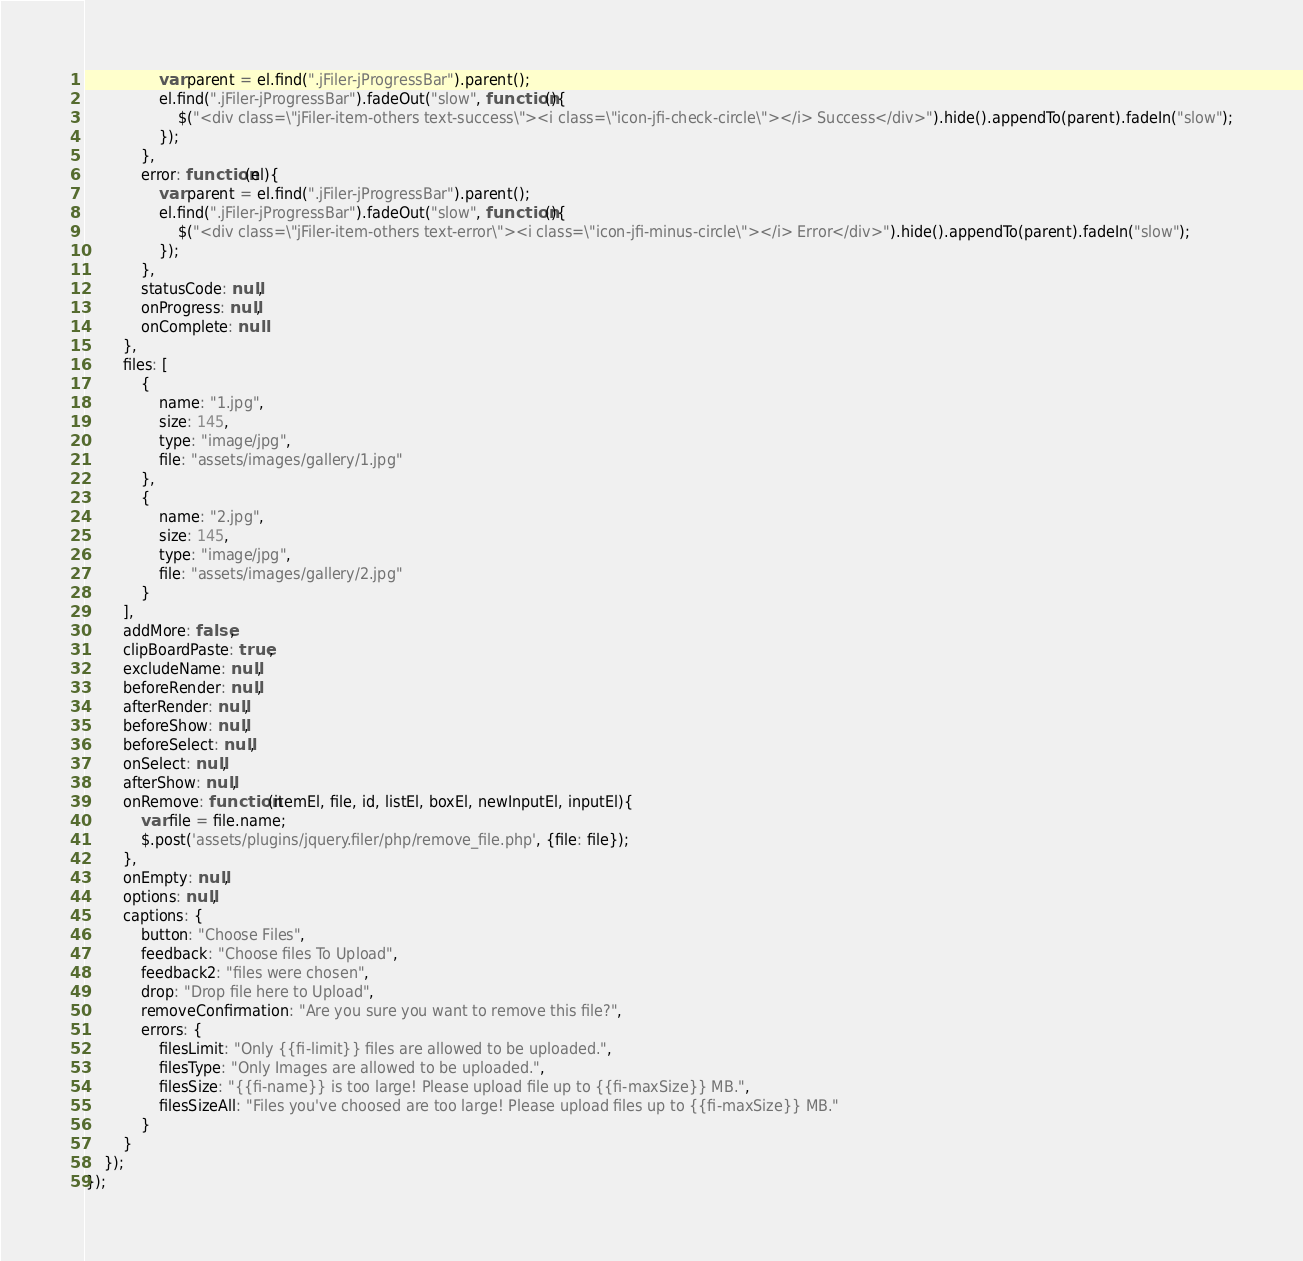<code> <loc_0><loc_0><loc_500><loc_500><_JavaScript_>                var parent = el.find(".jFiler-jProgressBar").parent();
                el.find(".jFiler-jProgressBar").fadeOut("slow", function(){
                    $("<div class=\"jFiler-item-others text-success\"><i class=\"icon-jfi-check-circle\"></i> Success</div>").hide().appendTo(parent).fadeIn("slow");
                });
            },
            error: function(el){
                var parent = el.find(".jFiler-jProgressBar").parent();
                el.find(".jFiler-jProgressBar").fadeOut("slow", function(){
                    $("<div class=\"jFiler-item-others text-error\"><i class=\"icon-jfi-minus-circle\"></i> Error</div>").hide().appendTo(parent).fadeIn("slow");
                });
            },
            statusCode: null,
            onProgress: null,
            onComplete: null
        },
		files: [
			{
				name: "1.jpg",
				size: 145,
				type: "image/jpg",
				file: "assets/images/gallery/1.jpg"
			},
			{
				name: "2.jpg",
				size: 145,
				type: "image/jpg",
				file: "assets/images/gallery/2.jpg"
			}
		],
        addMore: false,
        clipBoardPaste: true,
        excludeName: null,
        beforeRender: null,
        afterRender: null,
        beforeShow: null,
        beforeSelect: null,
        onSelect: null,
        afterShow: null,
        onRemove: function(itemEl, file, id, listEl, boxEl, newInputEl, inputEl){
            var file = file.name;
            $.post('assets/plugins/jquery.filer/php/remove_file.php', {file: file});
        },
        onEmpty: null,
        options: null,
        captions: {
            button: "Choose Files",
            feedback: "Choose files To Upload",
            feedback2: "files were chosen",
            drop: "Drop file here to Upload",
            removeConfirmation: "Are you sure you want to remove this file?",
            errors: {
                filesLimit: "Only {{fi-limit}} files are allowed to be uploaded.",
                filesType: "Only Images are allowed to be uploaded.",
                filesSize: "{{fi-name}} is too large! Please upload file up to {{fi-maxSize}} MB.",
                filesSizeAll: "Files you've choosed are too large! Please upload files up to {{fi-maxSize}} MB."
            }
        }
    });
});</code> 